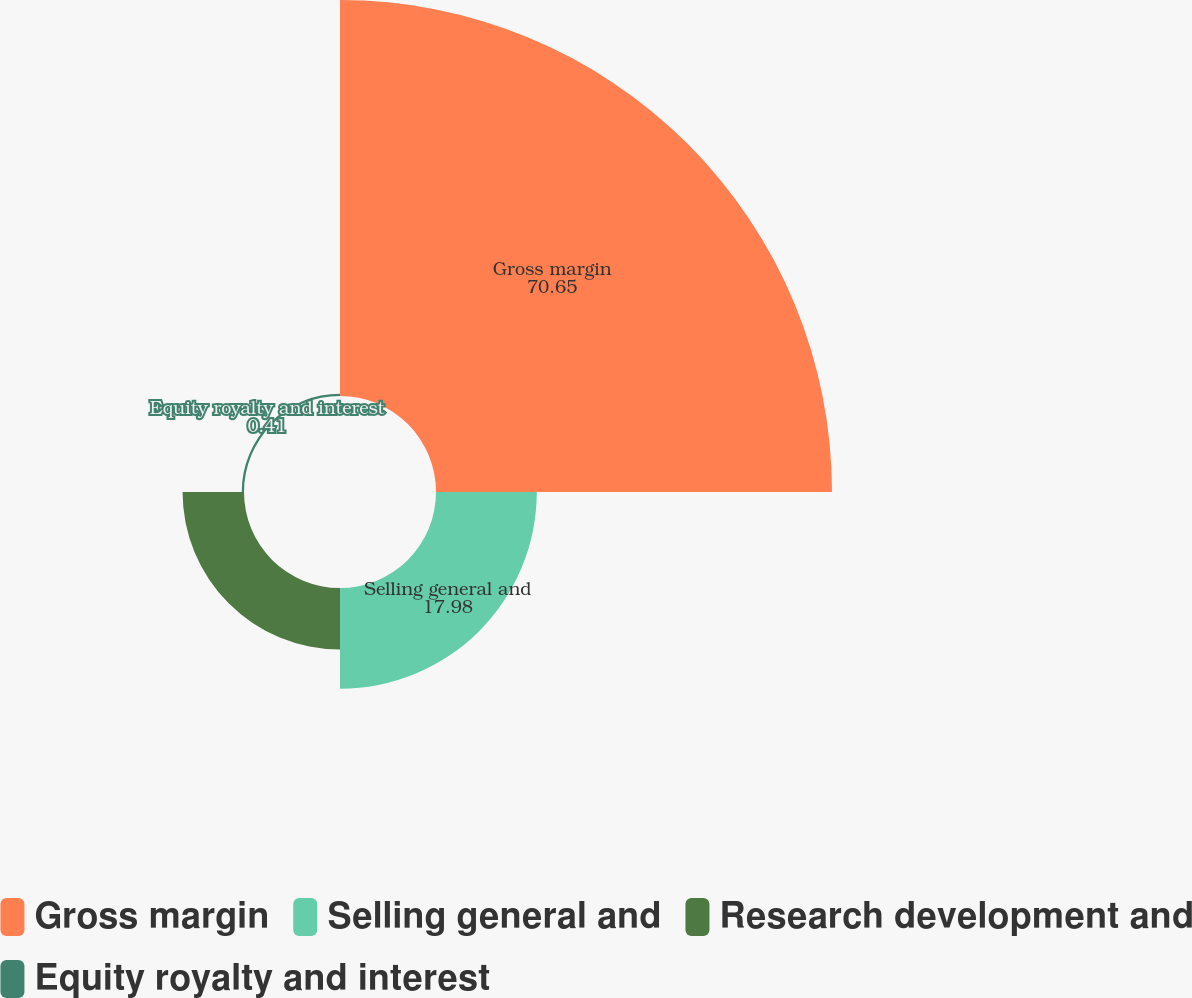Convert chart. <chart><loc_0><loc_0><loc_500><loc_500><pie_chart><fcel>Gross margin<fcel>Selling general and<fcel>Research development and<fcel>Equity royalty and interest<nl><fcel>70.65%<fcel>17.98%<fcel>10.96%<fcel>0.41%<nl></chart> 